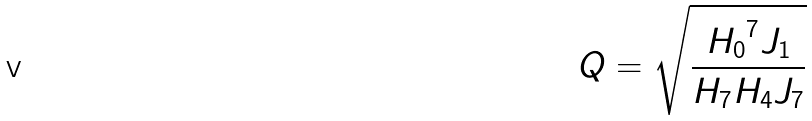Convert formula to latex. <formula><loc_0><loc_0><loc_500><loc_500>Q = \sqrt { \frac { { H _ { 0 } } ^ { 7 } J _ { 1 } } { H _ { 7 } H _ { 4 } J _ { 7 } } }</formula> 